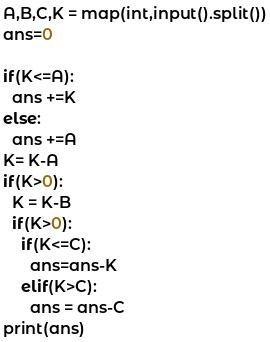Convert code to text. <code><loc_0><loc_0><loc_500><loc_500><_Python_>A,B,C,K = map(int,input().split())
ans=0

if(K<=A):
  ans +=K
else:
  ans +=A
K= K-A
if(K>0):
  K = K-B
  if(K>0):
    if(K<=C):
      ans=ans-K
    elif(K>C):
      ans = ans-C
print(ans)

</code> 